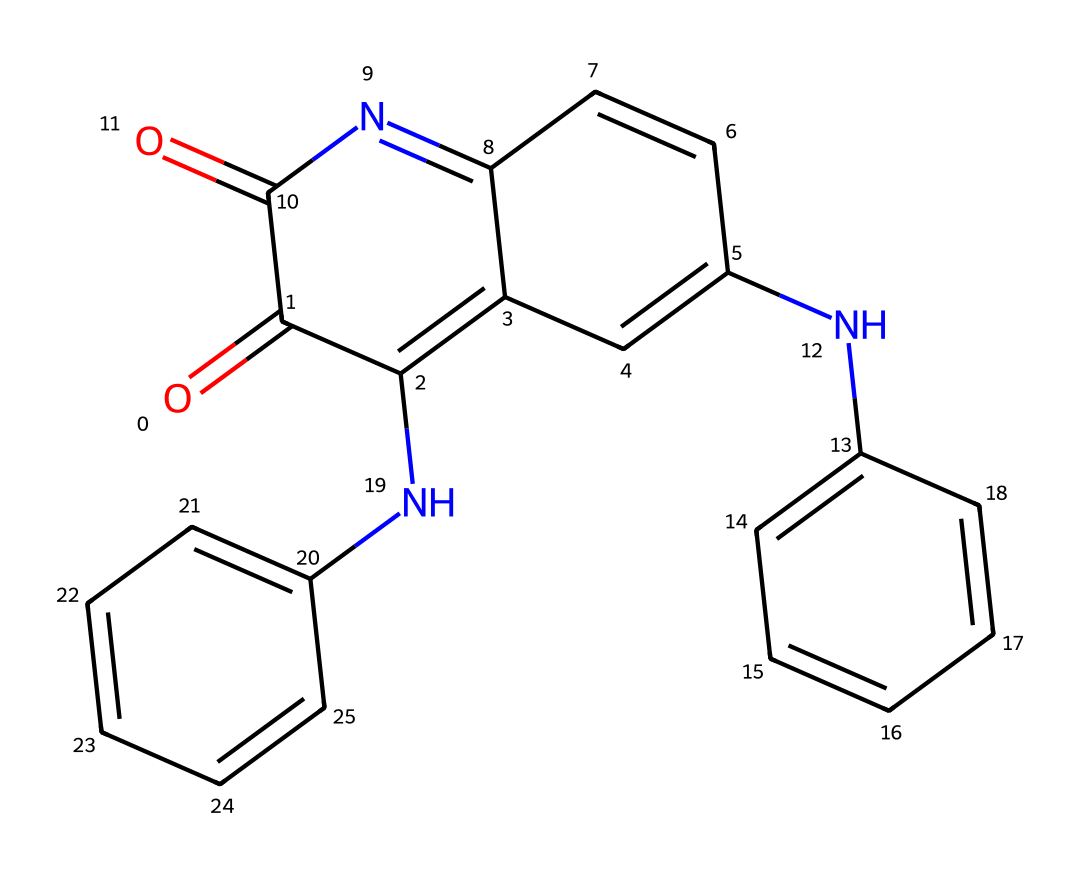What is the molecular formula of this dye? To determine the molecular formula, we need to count the number of carbon (C), hydrogen (H), nitrogen (N), and oxygen (O) atoms in the chemical structure represented by the SMILES. There are 16 carbons, 12 hydrogens, 4 nitrogens, and 2 oxygens. Therefore, the molecular formula is C16H12N2O2.
Answer: C16H12N2O2 How many rings are present in the structure? By visualizing the chemical structure, we notice that there are multiple interconnected cycles. Counting these cycles, we find there are four distinct rings in the chemical structure.
Answer: 4 What kind of interactions can this dye participate in due to its functional groups? The presence of nitrogen and oxygen atoms in the structure suggests that this dye can participate in hydrogen bonding interactions. Additionally, the conjugated double bonds might allow for π-π stacking interactions with other aromatic systems.
Answer: hydrogen bonding What is the significance of the nitrogen atoms in the structure? Nitrogen atoms can act as electron pair donors and may influence the color properties of the dye. Moreover, their presence indicates that the dye could exhibit basic characteristics and reactivity, impacting the dyeing process in textiles.
Answer: basic characteristics Is this dye considered a natural or synthetic dye? Indigo is traditionally known as a natural dye extracted from plants, specifically plants like Indigofera. Although synthetic indigo is also produced, the historical significance and extraction from natural sources suggest it is primarily a natural dye.
Answer: natural How many double bonds are present in this dye structure? By analyzing the chemical structure, we observe the presence of several carbon-carbon double bonds. Specifically, there are 6 double bonds in the structure of this dye, contributing to its resonance and stability.
Answer: 6 